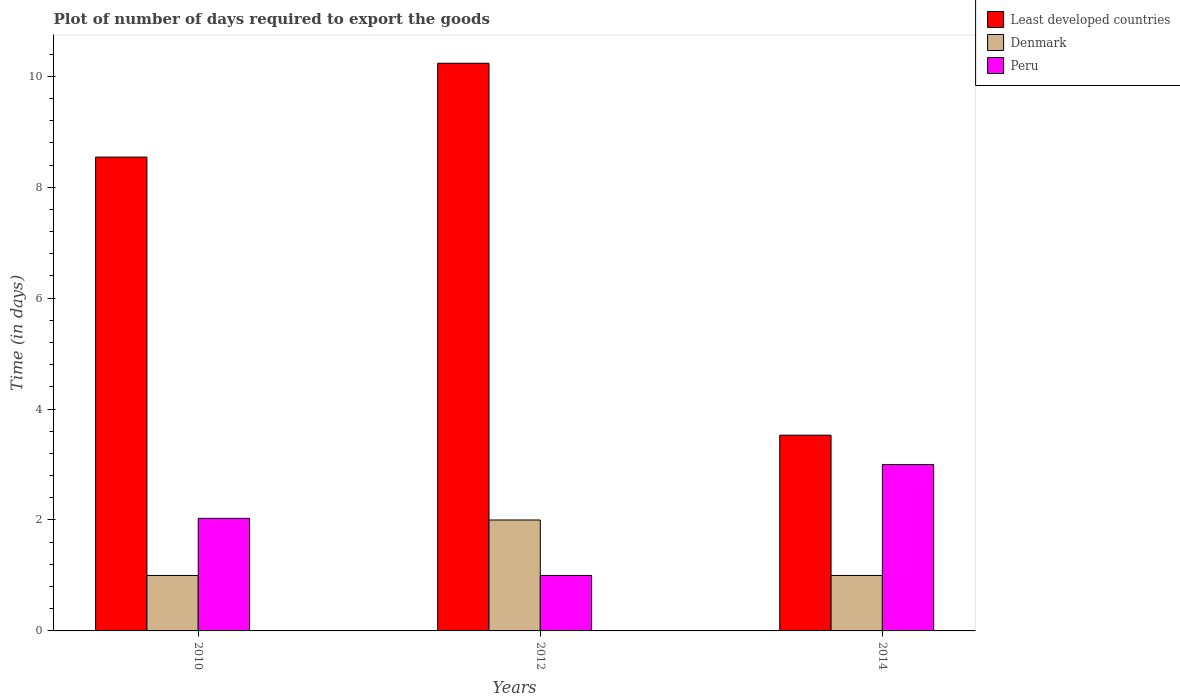How many different coloured bars are there?
Provide a short and direct response. 3. How many groups of bars are there?
Ensure brevity in your answer.  3. Are the number of bars on each tick of the X-axis equal?
Offer a terse response. Yes. How many bars are there on the 1st tick from the right?
Give a very brief answer. 3. What is the time required to export goods in Least developed countries in 2014?
Offer a terse response. 3.53. Across all years, what is the maximum time required to export goods in Denmark?
Make the answer very short. 2. In which year was the time required to export goods in Least developed countries maximum?
Your response must be concise. 2012. In which year was the time required to export goods in Denmark minimum?
Your answer should be very brief. 2010. What is the total time required to export goods in Peru in the graph?
Ensure brevity in your answer.  6.03. What is the difference between the time required to export goods in Peru in 2010 and that in 2012?
Keep it short and to the point. 1.03. What is the difference between the time required to export goods in Peru in 2010 and the time required to export goods in Denmark in 2012?
Offer a terse response. 0.03. What is the average time required to export goods in Peru per year?
Provide a succinct answer. 2.01. In the year 2010, what is the difference between the time required to export goods in Peru and time required to export goods in Denmark?
Offer a very short reply. 1.03. What is the ratio of the time required to export goods in Least developed countries in 2012 to that in 2014?
Offer a terse response. 2.9. Is the time required to export goods in Peru in 2010 less than that in 2014?
Your response must be concise. Yes. What is the difference between the highest and the second highest time required to export goods in Peru?
Keep it short and to the point. 0.97. What is the difference between two consecutive major ticks on the Y-axis?
Your answer should be very brief. 2. Where does the legend appear in the graph?
Give a very brief answer. Top right. What is the title of the graph?
Ensure brevity in your answer.  Plot of number of days required to export the goods. Does "Syrian Arab Republic" appear as one of the legend labels in the graph?
Your response must be concise. No. What is the label or title of the Y-axis?
Offer a very short reply. Time (in days). What is the Time (in days) of Least developed countries in 2010?
Offer a very short reply. 8.54. What is the Time (in days) in Peru in 2010?
Your response must be concise. 2.03. What is the Time (in days) in Least developed countries in 2012?
Your answer should be very brief. 10.24. What is the Time (in days) of Least developed countries in 2014?
Keep it short and to the point. 3.53. What is the Time (in days) in Denmark in 2014?
Provide a short and direct response. 1. What is the Time (in days) in Peru in 2014?
Provide a short and direct response. 3. Across all years, what is the maximum Time (in days) of Least developed countries?
Your answer should be very brief. 10.24. Across all years, what is the maximum Time (in days) of Denmark?
Give a very brief answer. 2. Across all years, what is the maximum Time (in days) in Peru?
Make the answer very short. 3. Across all years, what is the minimum Time (in days) in Least developed countries?
Your answer should be compact. 3.53. What is the total Time (in days) of Least developed countries in the graph?
Your answer should be very brief. 22.31. What is the total Time (in days) in Peru in the graph?
Make the answer very short. 6.03. What is the difference between the Time (in days) of Least developed countries in 2010 and that in 2012?
Offer a very short reply. -1.69. What is the difference between the Time (in days) of Denmark in 2010 and that in 2012?
Your response must be concise. -1. What is the difference between the Time (in days) in Peru in 2010 and that in 2012?
Keep it short and to the point. 1.03. What is the difference between the Time (in days) of Least developed countries in 2010 and that in 2014?
Your response must be concise. 5.01. What is the difference between the Time (in days) in Peru in 2010 and that in 2014?
Ensure brevity in your answer.  -0.97. What is the difference between the Time (in days) of Least developed countries in 2012 and that in 2014?
Ensure brevity in your answer.  6.71. What is the difference between the Time (in days) of Denmark in 2012 and that in 2014?
Your response must be concise. 1. What is the difference between the Time (in days) of Peru in 2012 and that in 2014?
Your answer should be compact. -2. What is the difference between the Time (in days) of Least developed countries in 2010 and the Time (in days) of Denmark in 2012?
Make the answer very short. 6.54. What is the difference between the Time (in days) in Least developed countries in 2010 and the Time (in days) in Peru in 2012?
Your response must be concise. 7.54. What is the difference between the Time (in days) in Least developed countries in 2010 and the Time (in days) in Denmark in 2014?
Keep it short and to the point. 7.54. What is the difference between the Time (in days) of Least developed countries in 2010 and the Time (in days) of Peru in 2014?
Your answer should be very brief. 5.54. What is the difference between the Time (in days) in Denmark in 2010 and the Time (in days) in Peru in 2014?
Offer a very short reply. -2. What is the difference between the Time (in days) of Least developed countries in 2012 and the Time (in days) of Denmark in 2014?
Offer a very short reply. 9.24. What is the difference between the Time (in days) in Least developed countries in 2012 and the Time (in days) in Peru in 2014?
Make the answer very short. 7.24. What is the difference between the Time (in days) of Denmark in 2012 and the Time (in days) of Peru in 2014?
Ensure brevity in your answer.  -1. What is the average Time (in days) of Least developed countries per year?
Provide a succinct answer. 7.44. What is the average Time (in days) of Peru per year?
Give a very brief answer. 2.01. In the year 2010, what is the difference between the Time (in days) in Least developed countries and Time (in days) in Denmark?
Your answer should be very brief. 7.54. In the year 2010, what is the difference between the Time (in days) of Least developed countries and Time (in days) of Peru?
Your answer should be compact. 6.51. In the year 2010, what is the difference between the Time (in days) of Denmark and Time (in days) of Peru?
Keep it short and to the point. -1.03. In the year 2012, what is the difference between the Time (in days) of Least developed countries and Time (in days) of Denmark?
Give a very brief answer. 8.24. In the year 2012, what is the difference between the Time (in days) in Least developed countries and Time (in days) in Peru?
Provide a succinct answer. 9.24. In the year 2014, what is the difference between the Time (in days) of Least developed countries and Time (in days) of Denmark?
Your answer should be very brief. 2.53. In the year 2014, what is the difference between the Time (in days) in Least developed countries and Time (in days) in Peru?
Offer a very short reply. 0.53. In the year 2014, what is the difference between the Time (in days) in Denmark and Time (in days) in Peru?
Make the answer very short. -2. What is the ratio of the Time (in days) in Least developed countries in 2010 to that in 2012?
Your response must be concise. 0.83. What is the ratio of the Time (in days) in Denmark in 2010 to that in 2012?
Offer a terse response. 0.5. What is the ratio of the Time (in days) in Peru in 2010 to that in 2012?
Keep it short and to the point. 2.03. What is the ratio of the Time (in days) of Least developed countries in 2010 to that in 2014?
Your response must be concise. 2.42. What is the ratio of the Time (in days) in Peru in 2010 to that in 2014?
Your answer should be compact. 0.68. What is the ratio of the Time (in days) of Peru in 2012 to that in 2014?
Offer a very short reply. 0.33. What is the difference between the highest and the second highest Time (in days) in Least developed countries?
Offer a very short reply. 1.69. What is the difference between the highest and the second highest Time (in days) in Peru?
Your answer should be very brief. 0.97. What is the difference between the highest and the lowest Time (in days) of Least developed countries?
Ensure brevity in your answer.  6.71. What is the difference between the highest and the lowest Time (in days) of Peru?
Your response must be concise. 2. 